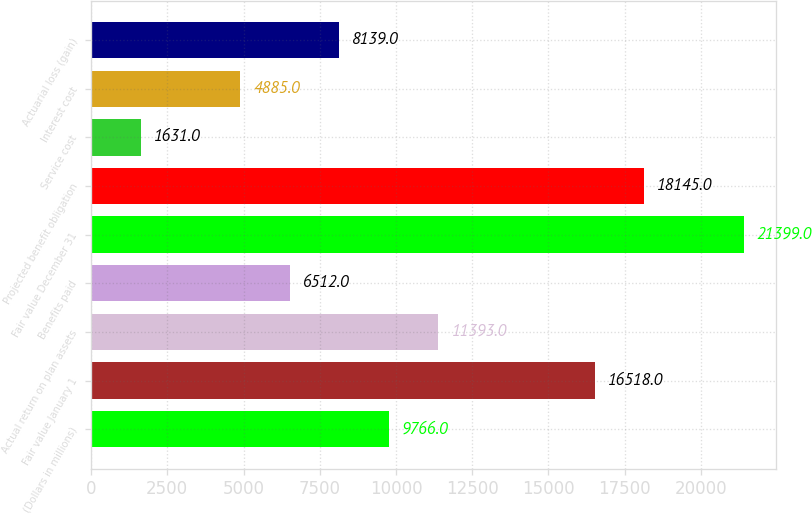Convert chart to OTSL. <chart><loc_0><loc_0><loc_500><loc_500><bar_chart><fcel>(Dollars in millions)<fcel>Fair value January 1<fcel>Actual return on plan assets<fcel>Benefits paid<fcel>Fair value December 31<fcel>Projected benefit obligation<fcel>Service cost<fcel>Interest cost<fcel>Actuarial loss (gain)<nl><fcel>9766<fcel>16518<fcel>11393<fcel>6512<fcel>21399<fcel>18145<fcel>1631<fcel>4885<fcel>8139<nl></chart> 